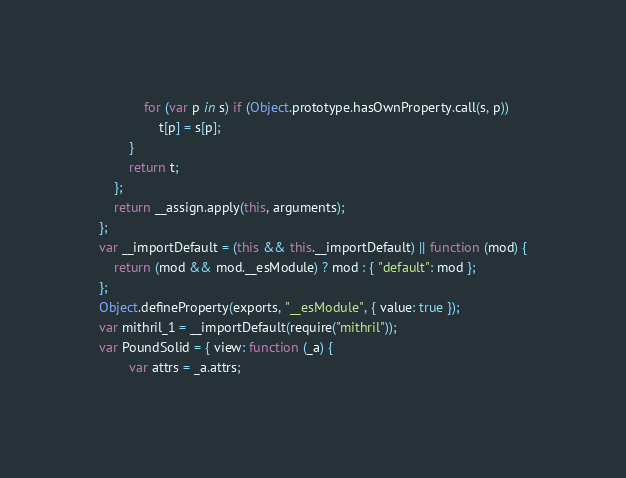<code> <loc_0><loc_0><loc_500><loc_500><_JavaScript_>            for (var p in s) if (Object.prototype.hasOwnProperty.call(s, p))
                t[p] = s[p];
        }
        return t;
    };
    return __assign.apply(this, arguments);
};
var __importDefault = (this && this.__importDefault) || function (mod) {
    return (mod && mod.__esModule) ? mod : { "default": mod };
};
Object.defineProperty(exports, "__esModule", { value: true });
var mithril_1 = __importDefault(require("mithril"));
var PoundSolid = { view: function (_a) {
        var attrs = _a.attrs;</code> 